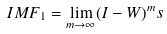Convert formula to latex. <formula><loc_0><loc_0><loc_500><loc_500>I M F _ { 1 } = \lim _ { m \rightarrow \infty } ( I - W ) ^ { m } s</formula> 